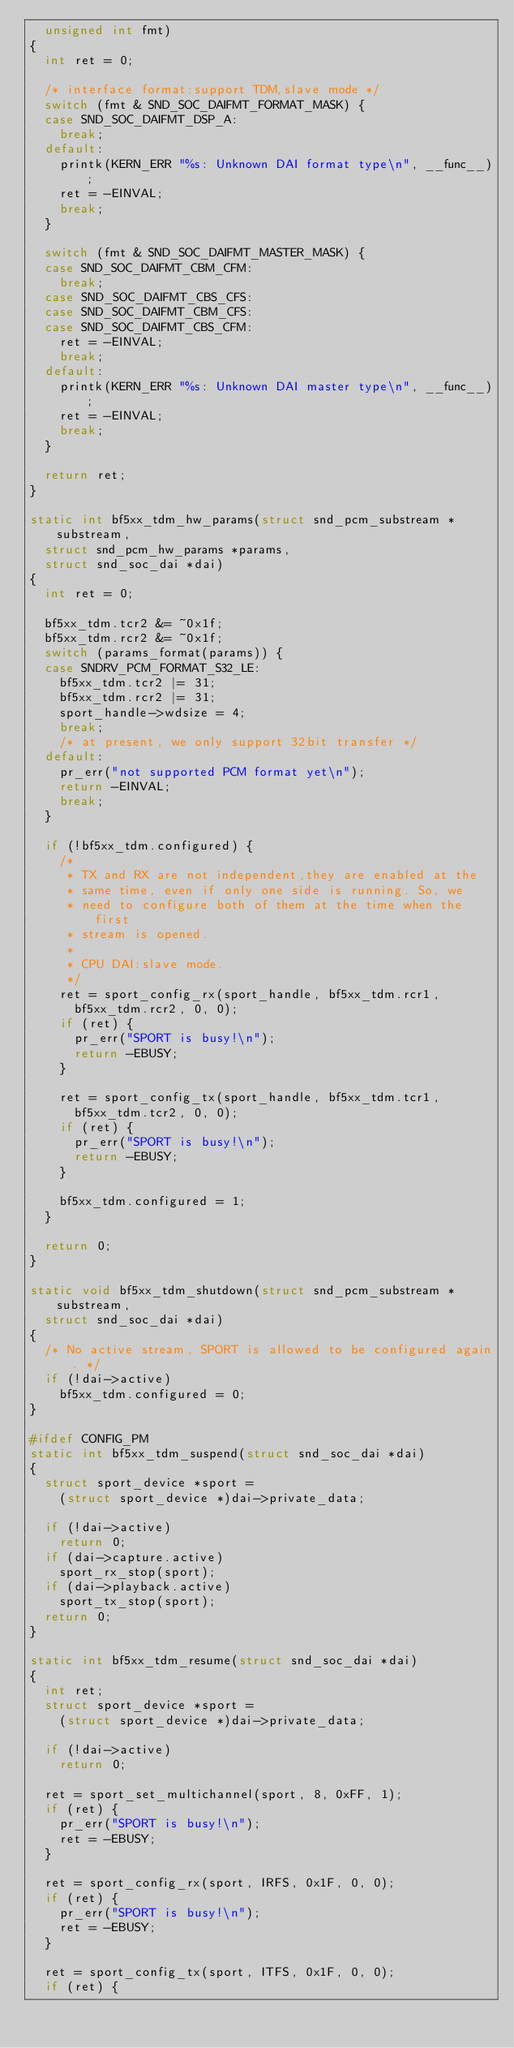Convert code to text. <code><loc_0><loc_0><loc_500><loc_500><_C_>	unsigned int fmt)
{
	int ret = 0;

	/* interface format:support TDM,slave mode */
	switch (fmt & SND_SOC_DAIFMT_FORMAT_MASK) {
	case SND_SOC_DAIFMT_DSP_A:
		break;
	default:
		printk(KERN_ERR "%s: Unknown DAI format type\n", __func__);
		ret = -EINVAL;
		break;
	}

	switch (fmt & SND_SOC_DAIFMT_MASTER_MASK) {
	case SND_SOC_DAIFMT_CBM_CFM:
		break;
	case SND_SOC_DAIFMT_CBS_CFS:
	case SND_SOC_DAIFMT_CBM_CFS:
	case SND_SOC_DAIFMT_CBS_CFM:
		ret = -EINVAL;
		break;
	default:
		printk(KERN_ERR "%s: Unknown DAI master type\n", __func__);
		ret = -EINVAL;
		break;
	}

	return ret;
}

static int bf5xx_tdm_hw_params(struct snd_pcm_substream *substream,
	struct snd_pcm_hw_params *params,
	struct snd_soc_dai *dai)
{
	int ret = 0;

	bf5xx_tdm.tcr2 &= ~0x1f;
	bf5xx_tdm.rcr2 &= ~0x1f;
	switch (params_format(params)) {
	case SNDRV_PCM_FORMAT_S32_LE:
		bf5xx_tdm.tcr2 |= 31;
		bf5xx_tdm.rcr2 |= 31;
		sport_handle->wdsize = 4;
		break;
		/* at present, we only support 32bit transfer */
	default:
		pr_err("not supported PCM format yet\n");
		return -EINVAL;
		break;
	}

	if (!bf5xx_tdm.configured) {
		/*
		 * TX and RX are not independent,they are enabled at the
		 * same time, even if only one side is running. So, we
		 * need to configure both of them at the time when the first
		 * stream is opened.
		 *
		 * CPU DAI:slave mode.
		 */
		ret = sport_config_rx(sport_handle, bf5xx_tdm.rcr1,
			bf5xx_tdm.rcr2, 0, 0);
		if (ret) {
			pr_err("SPORT is busy!\n");
			return -EBUSY;
		}

		ret = sport_config_tx(sport_handle, bf5xx_tdm.tcr1,
			bf5xx_tdm.tcr2, 0, 0);
		if (ret) {
			pr_err("SPORT is busy!\n");
			return -EBUSY;
		}

		bf5xx_tdm.configured = 1;
	}

	return 0;
}

static void bf5xx_tdm_shutdown(struct snd_pcm_substream *substream,
	struct snd_soc_dai *dai)
{
	/* No active stream, SPORT is allowed to be configured again. */
	if (!dai->active)
		bf5xx_tdm.configured = 0;
}

#ifdef CONFIG_PM
static int bf5xx_tdm_suspend(struct snd_soc_dai *dai)
{
	struct sport_device *sport =
		(struct sport_device *)dai->private_data;

	if (!dai->active)
		return 0;
	if (dai->capture.active)
		sport_rx_stop(sport);
	if (dai->playback.active)
		sport_tx_stop(sport);
	return 0;
}

static int bf5xx_tdm_resume(struct snd_soc_dai *dai)
{
	int ret;
	struct sport_device *sport =
		(struct sport_device *)dai->private_data;

	if (!dai->active)
		return 0;

	ret = sport_set_multichannel(sport, 8, 0xFF, 1);
	if (ret) {
		pr_err("SPORT is busy!\n");
		ret = -EBUSY;
	}

	ret = sport_config_rx(sport, IRFS, 0x1F, 0, 0);
	if (ret) {
		pr_err("SPORT is busy!\n");
		ret = -EBUSY;
	}

	ret = sport_config_tx(sport, ITFS, 0x1F, 0, 0);
	if (ret) {</code> 